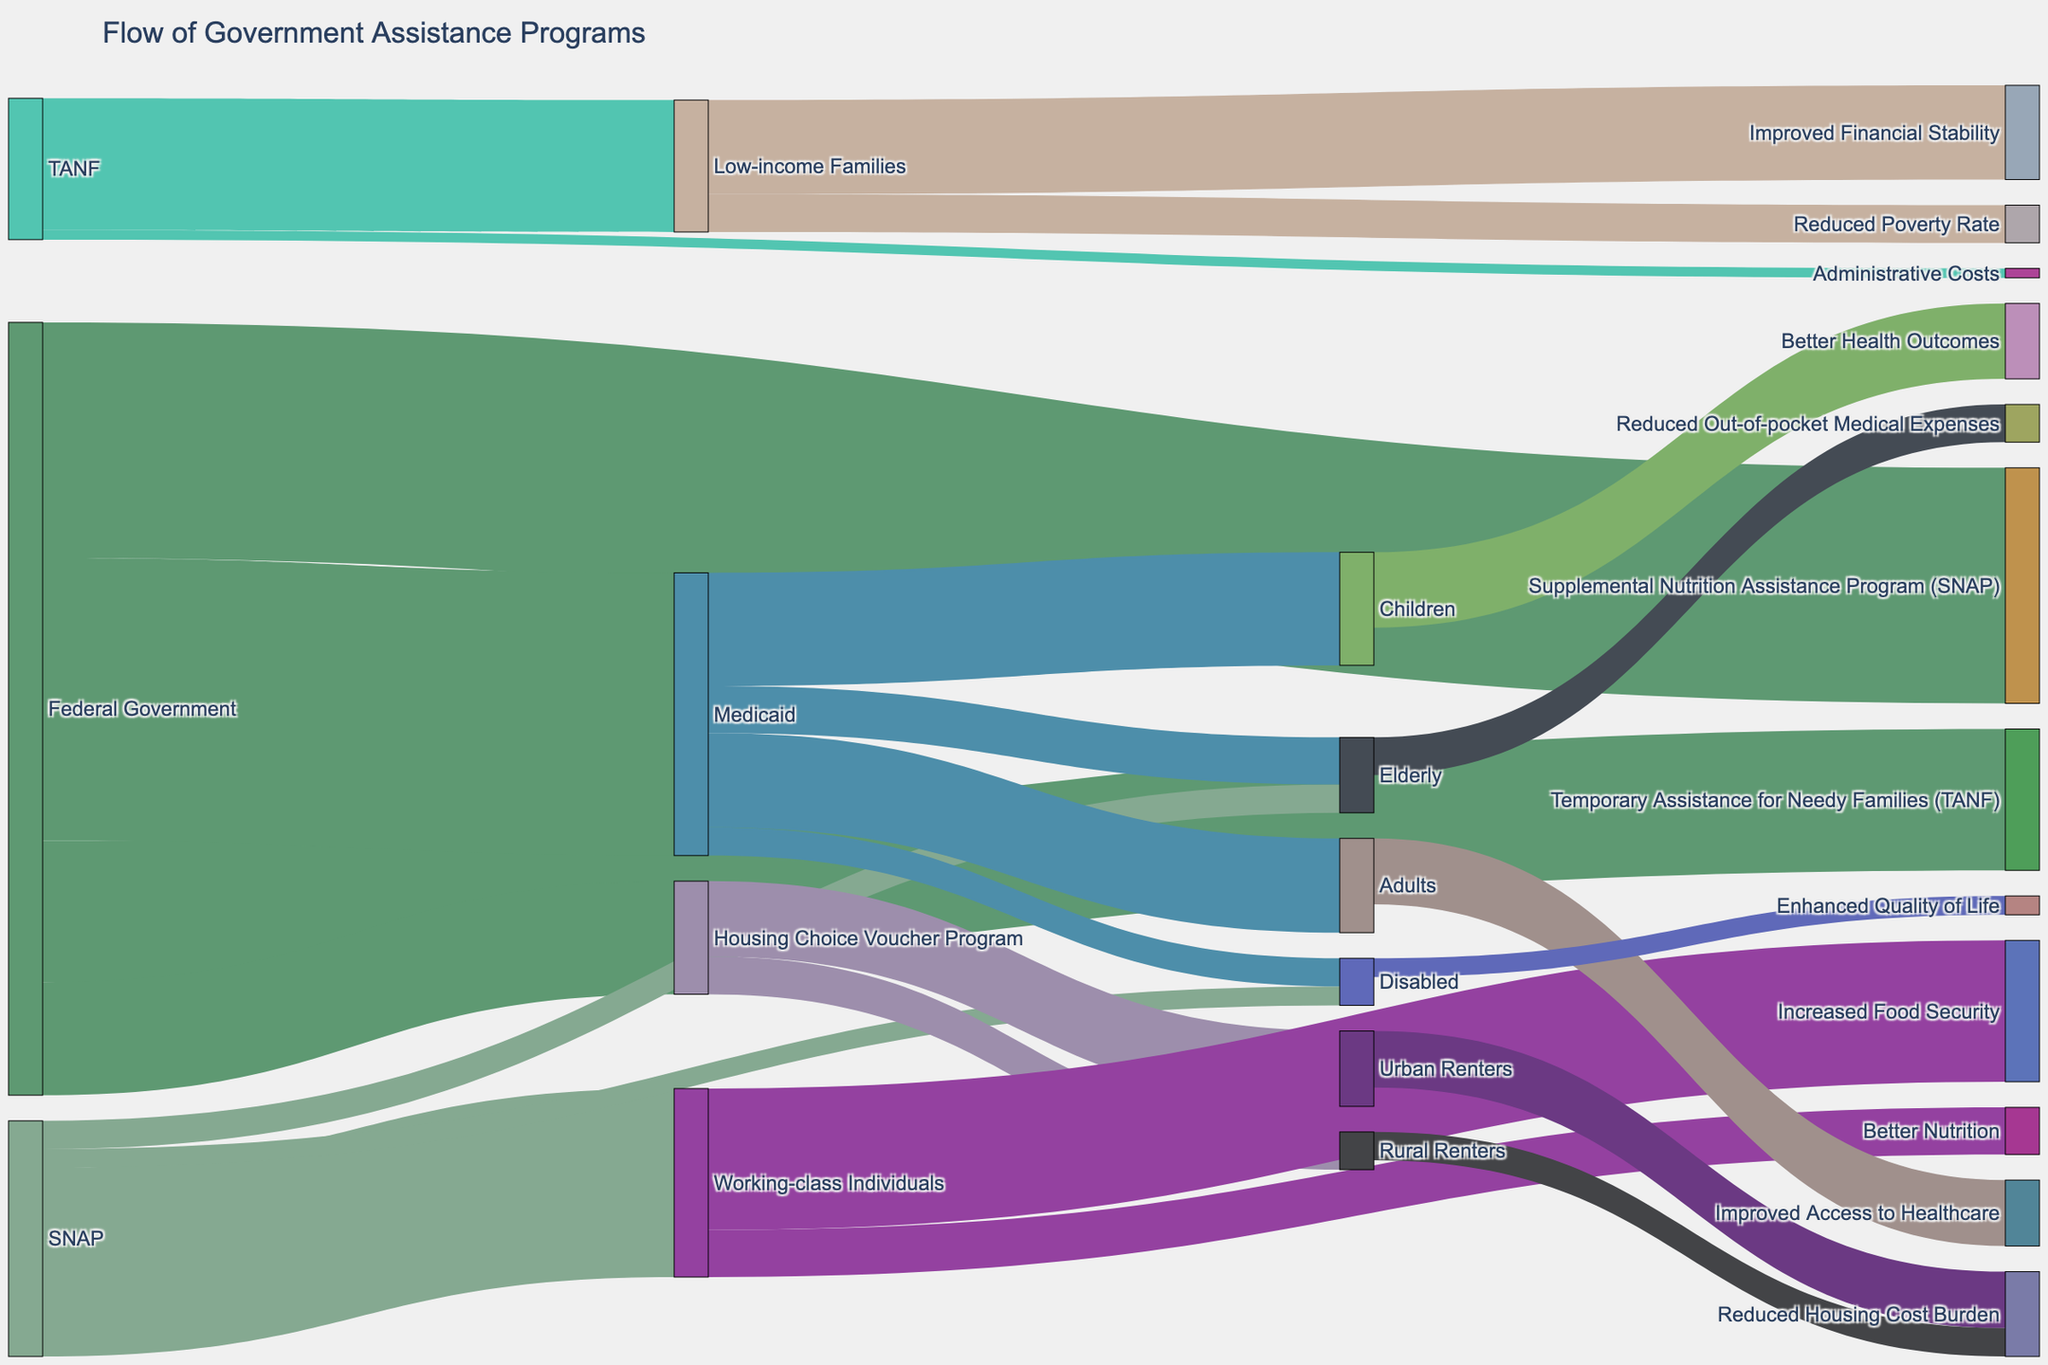what's the total amount of funding provided by the Federal Government to all the assistance programs? To find the total amount of funding provided by the Federal Government, we sum the values directed to each program: 15000 (TANF) + 25000 (SNAP) + 12000 (Housing Choice Voucher Program) + 30000 (Medicaid). The sum is 15000 + 25000 + 12000 + 30000 = 82000.
Answer: 82000 Which demographic group benefits the most from TANF? From the Sankey Diagram, TANF flows into two target groups: Low-income Families and Administrative Costs. By comparing the values, 14000 goes to Low-income Families, and 1000 goes to Administrative Costs. The group benefiting the most is Low-income Families.
Answer: Low-income Families Which program receives the largest amount of funding from the Federal Government? We need to compare the values that the Federal Government provides to each program: TANF (15000), SNAP (25000), Housing Choice Voucher Program (12000), and Medicaid (30000). The largest funding goes to Medicaid.
Answer: Medicaid How much total funding does the SNAP program contribute to Working-class Individuals? Within the SNAP program, the funding values are 20000 to Working-class Individuals, 3000 to Elderly, and 2000 to Disabled. Only need the value going directly to Working-class Individuals, which is 20000.
Answer: 20000 What is the combined total impact value of Medicaid on different demographic groups? Medicaid impacts Children, Adults, Elderly, and Disabled. Summing the impact values: Children (12000) + Adults (10000) + Elderly (5000) + Disabled (3000). Thus, 12000 + 10000 + 5000 + 3000 = 30000.
Answer: 30000 Does the SNAP or Medicaid program contribute more to Elderly beneficiaries? Comparing the values, SNAP contributes 3000 to the Elderly, and Medicaid contributes 5000 to the Elderly. Medicaid contributes more.
Answer: Medicaid What is the sum of funding from the Housing Choice Voucher Program going to Urban Renters and Rural Renters? To get the sum, add the values directed to Urban Renters and Rural Renters. 8000 (Urban Renters) + 4000 (Rural Renters) = 12000.
Answer: 12000 How does the value directed to Administrative Costs from TANF compare to that directed to Disabled beneficiaries from Medicaid? TANF directs 1000 to Administrative Costs, while Medicaid directs 3000 to Disabled beneficiaries. Comparing the two values, 3000 is greater than 1000.
Answer: 3000 > 1000 What is the overall impact value on Low-income Families from all sources combined? Low-income Families receive from TANF (14000), and these then flow into Improved Financial Stability (10000) and Reduced Poverty Rate (4000), totaling 14000. Hence, the impacts are Improved Financial Stability + Reduced Poverty Rate. Overall impact value = 14000.
Answer: 14000 